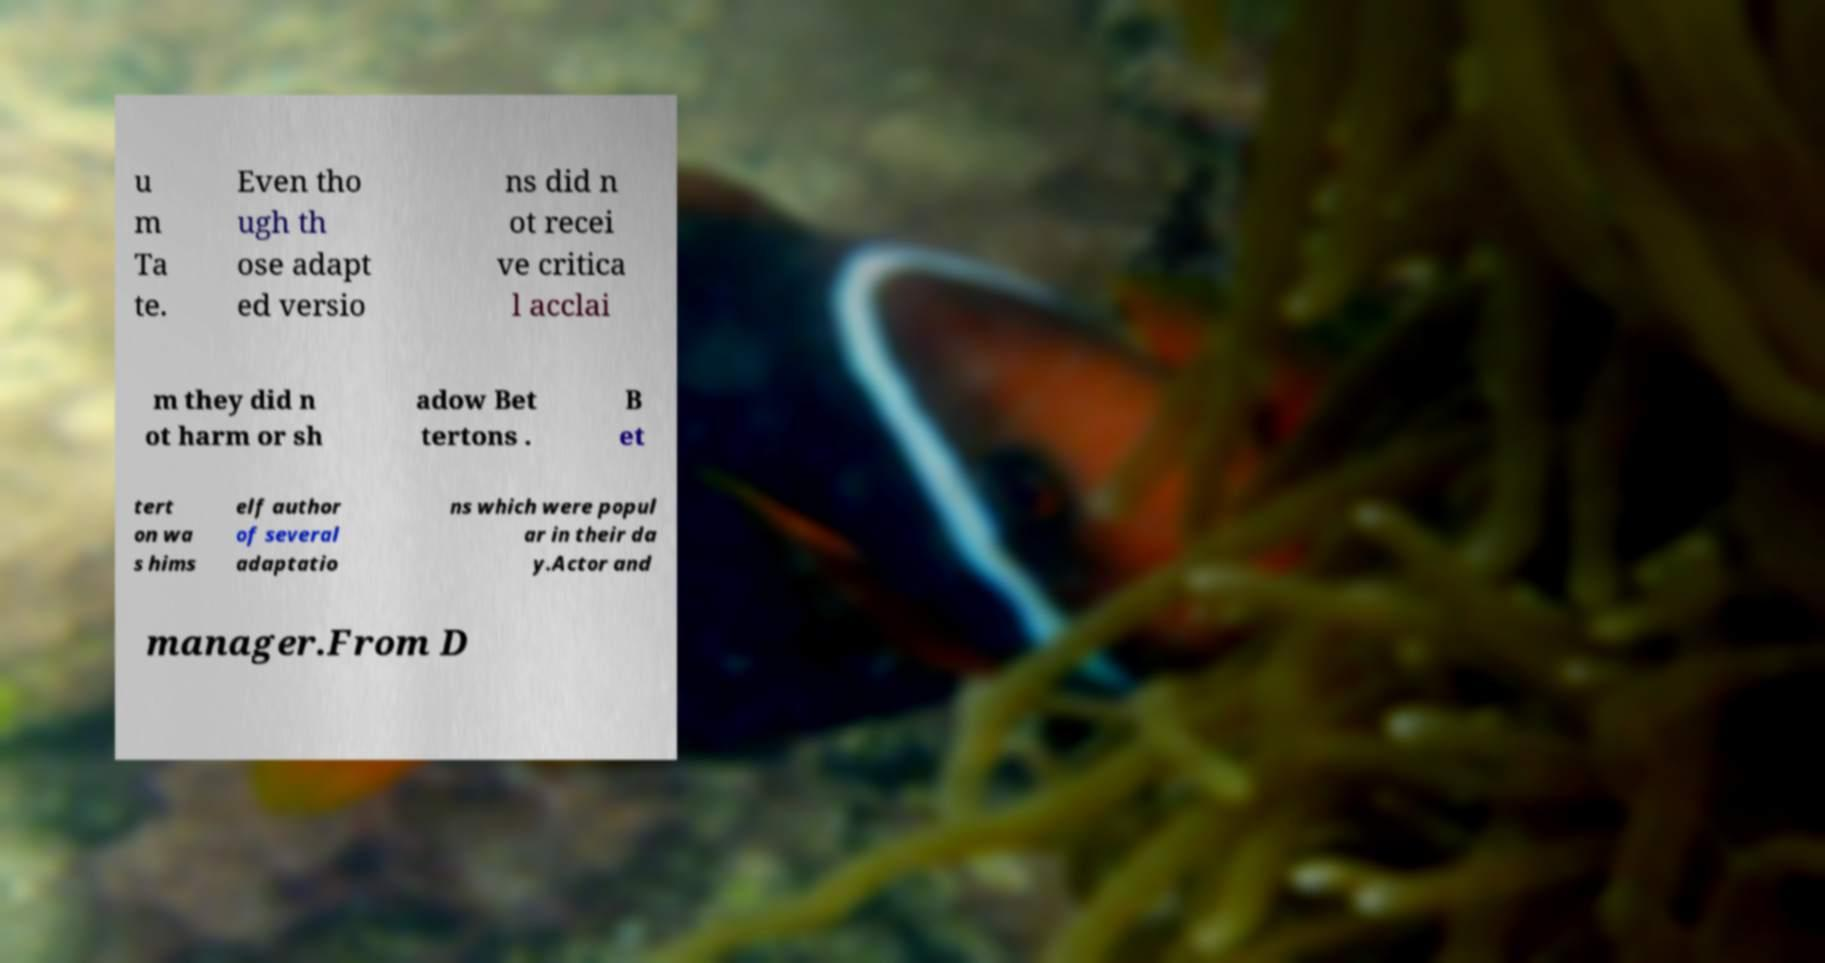For documentation purposes, I need the text within this image transcribed. Could you provide that? u m Ta te. Even tho ugh th ose adapt ed versio ns did n ot recei ve critica l acclai m they did n ot harm or sh adow Bet tertons . B et tert on wa s hims elf author of several adaptatio ns which were popul ar in their da y.Actor and manager.From D 